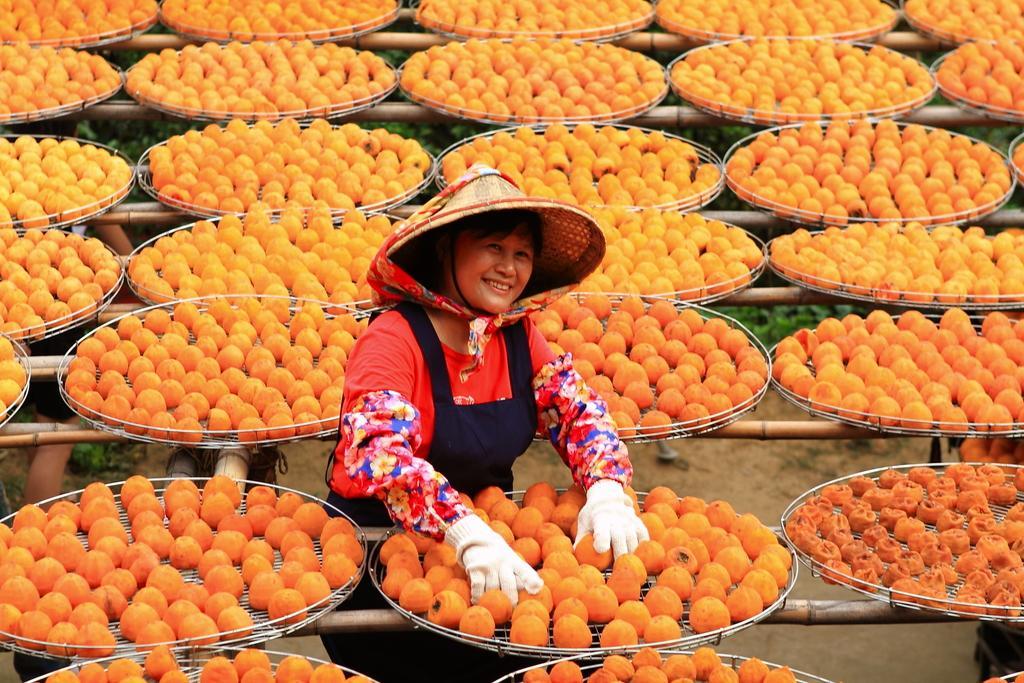Could you give a brief overview of what you see in this image? In this image there is a person having a smile on her face. Around her there are wooden poles. On top of it there are oranges in plates. At the bottom of the image there is grass on the surface. 